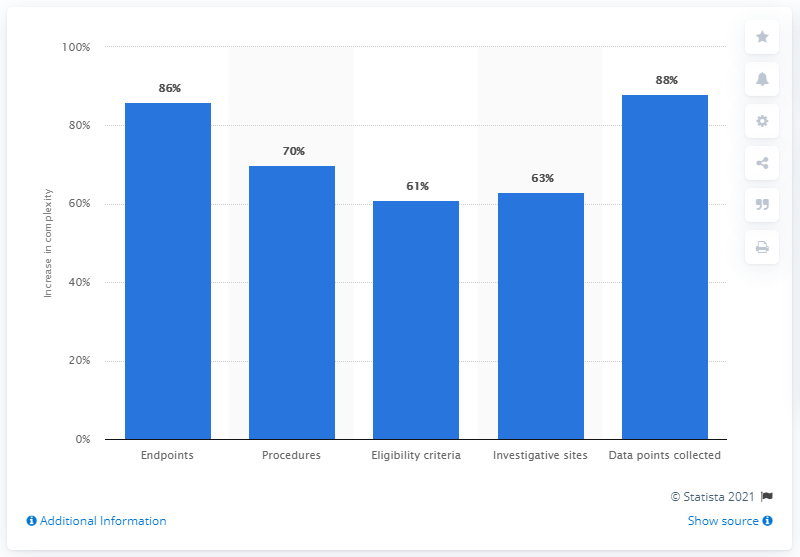Draw attention to some important aspects in this diagram. Between 2001-2005 and 2011-2015, the complexity of clinical trials increased by 61%. 